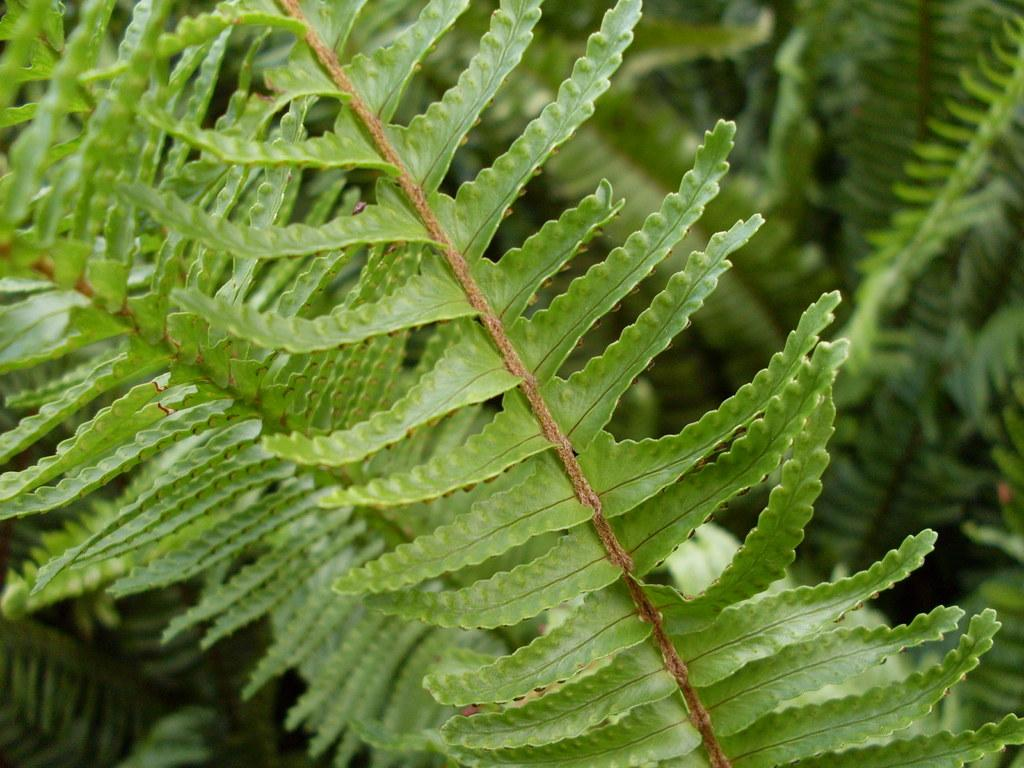What type of vegetation can be seen in the image? There are leaves in the image. Can you describe the background of the image? The background of the image is blurred. What type of bone is visible in the image? There is no bone present in the image; it only features leaves and a blurred background. 